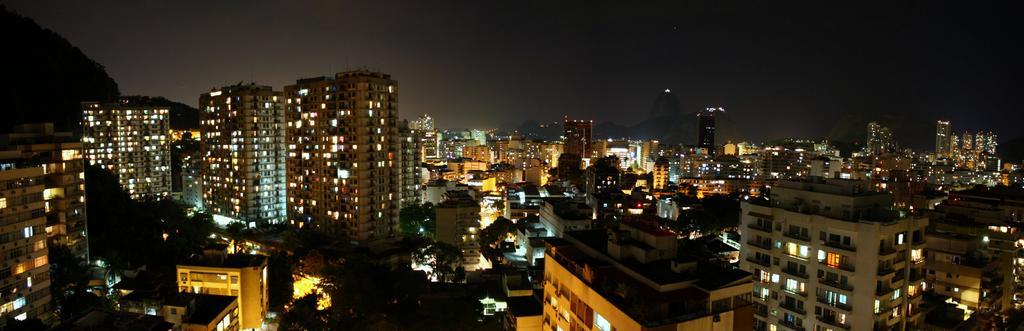What type of structures are present in the image? There are buildings in the image. What features can be observed on the buildings? The buildings have windows and lights. What type of vegetation is present on the ground? There are trees on the ground. How would you describe the background of the image? The background of the image is dark in color. Can you see any mist surrounding the buildings in the image? There is no mention of mist in the provided facts, so it cannot be determined if mist is present in the image. 